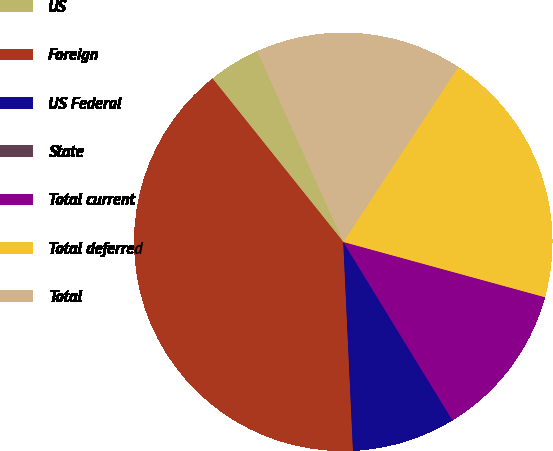Convert chart to OTSL. <chart><loc_0><loc_0><loc_500><loc_500><pie_chart><fcel>US<fcel>Foreign<fcel>US Federal<fcel>State<fcel>Total current<fcel>Total deferred<fcel>Total<nl><fcel>4.0%<fcel>40.0%<fcel>8.0%<fcel>0.0%<fcel>12.0%<fcel>20.0%<fcel>16.0%<nl></chart> 